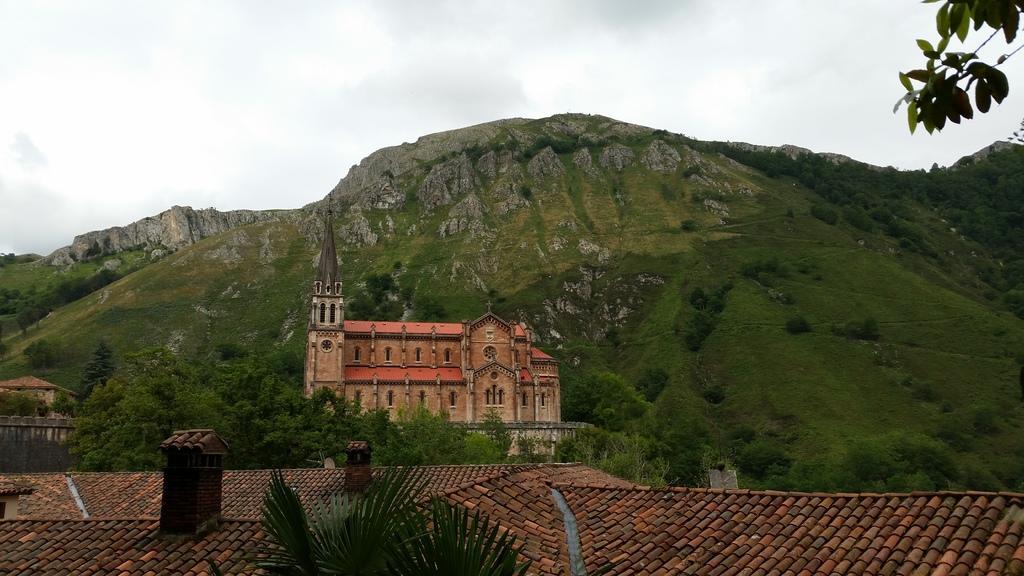Describe this image in one or two sentences. In this image I can see few trees which are green in color, the roof of the building and few other buildings. I can see a mountain and the sky in the background. 